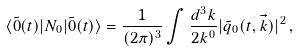<formula> <loc_0><loc_0><loc_500><loc_500>\langle \tilde { 0 } ( t ) | N _ { 0 } | \tilde { 0 } ( t ) \rangle = \frac { 1 } { ( 2 \pi ) ^ { 3 } } \int \frac { d ^ { 3 } k } { 2 k ^ { 0 } } | \tilde { q } _ { 0 } ( t , \vec { k } ) | ^ { 2 } \, ,</formula> 